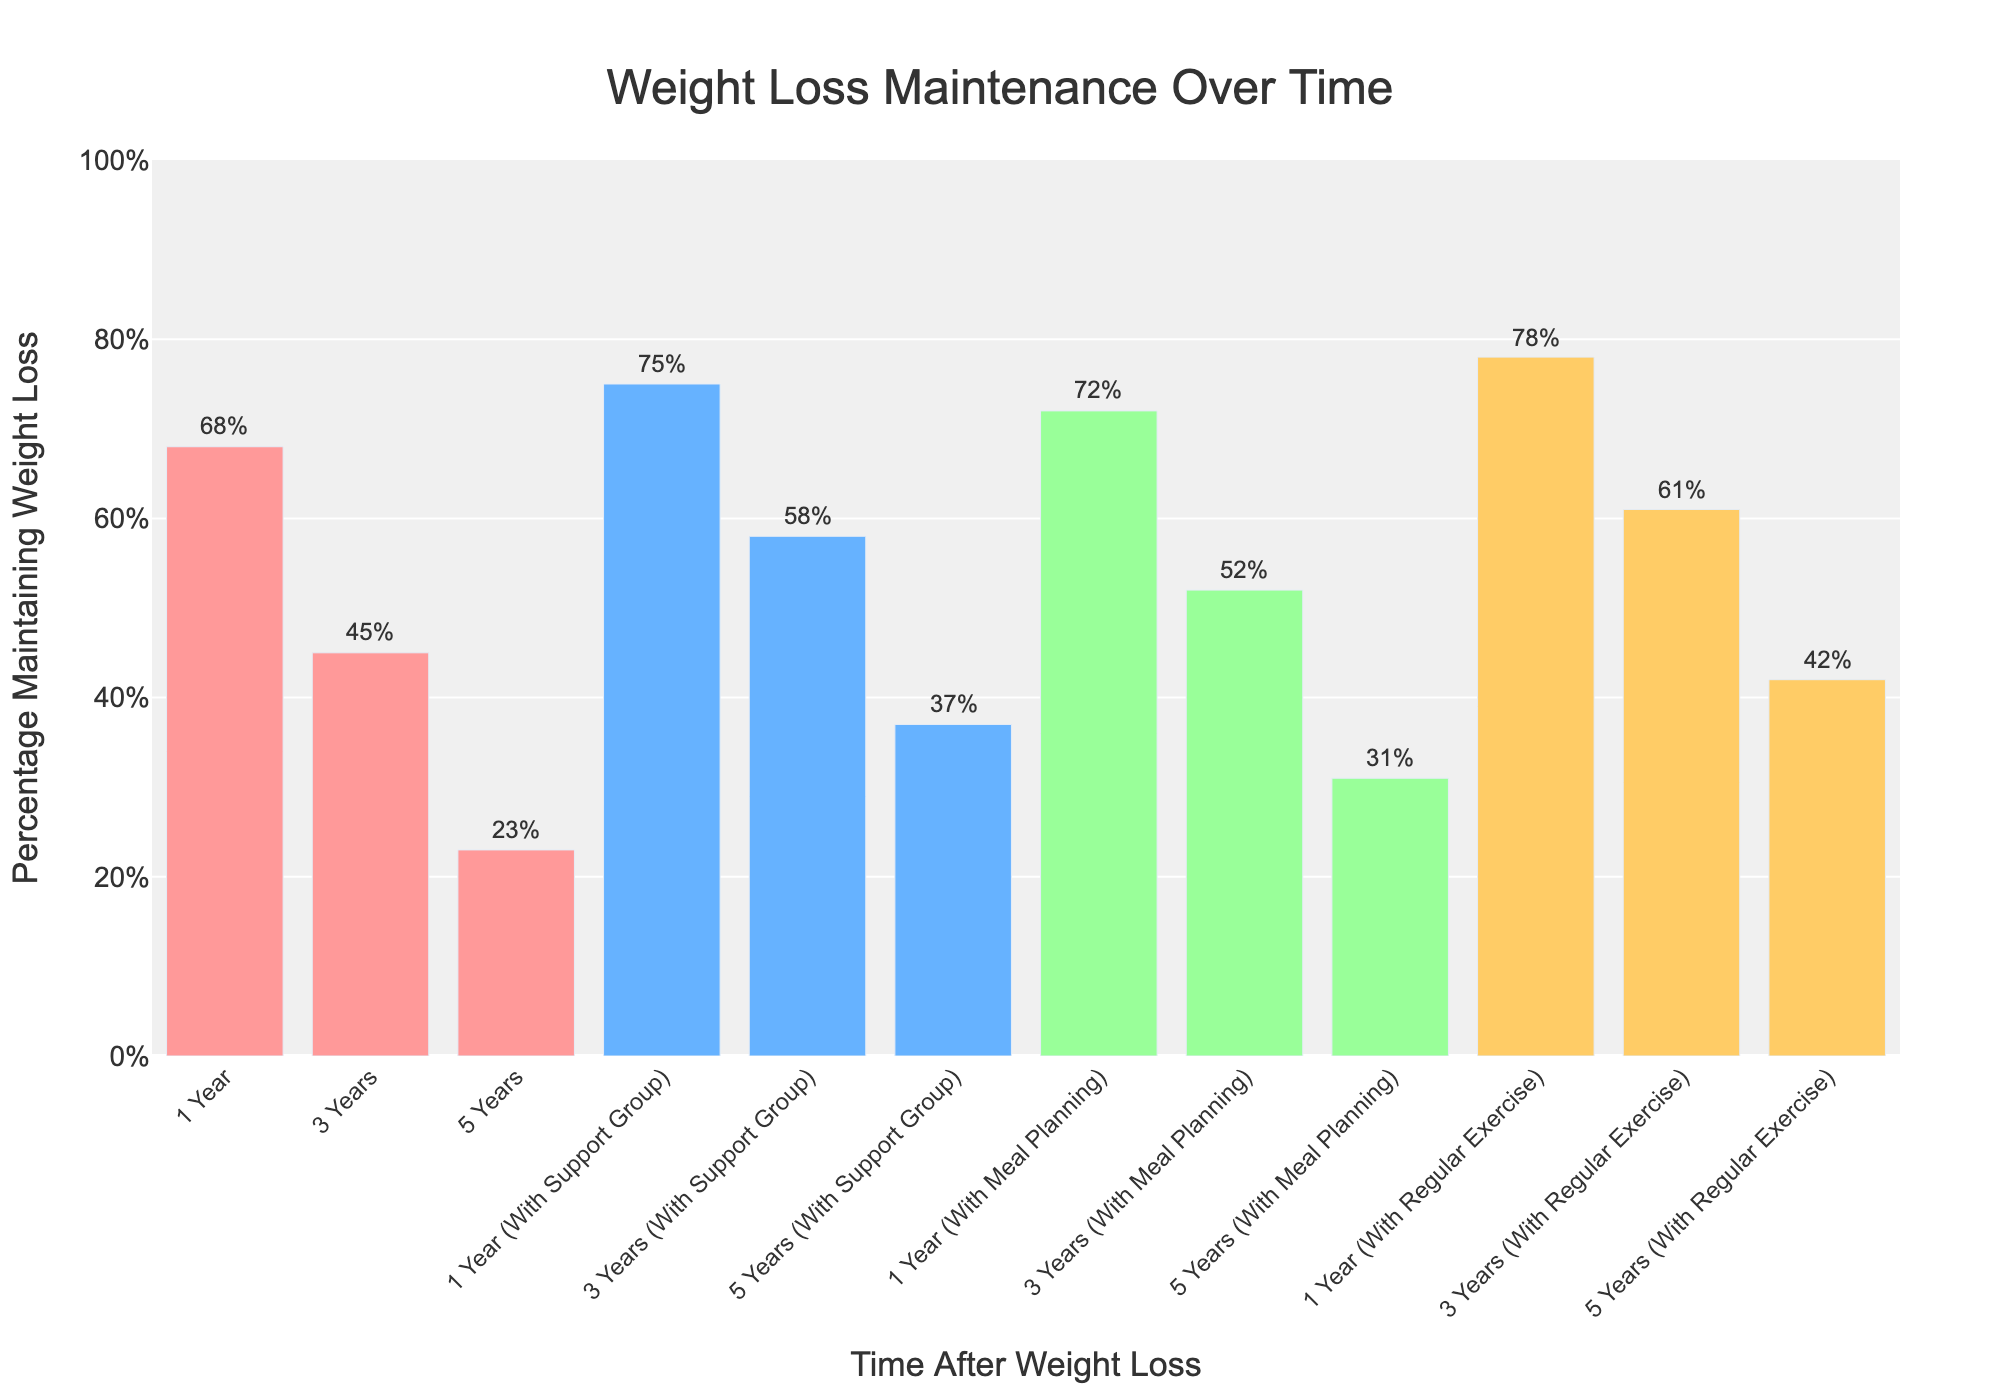Which group has the highest percentage of weight loss maintenance after 1 year? To find the group with the highest percentage of weight loss maintenance after 1 year, we compare the percentages: General (68%), With Support Group (75%), With Meal Planning (72%), and With Regular Exercise (78%). The highest percentage is With Regular Exercise at 78%.
Answer: With Regular Exercise Which group shows the largest decrease in percentage maintaining weight loss from 1 year to 5 years? To determine the largest decrease, we calculate the difference for each group from 1 year to 5 years: General (68% - 23% = 45%), With Support Group (75% - 37% = 38%), With Meal Planning (72% - 31% = 41%), With Regular Exercise (78% - 42% = 36%). The General group has the largest decrease.
Answer: General What is the average percentage of weight loss maintenance after 3 years for all groups? To find the average, sum the percentages of all groups after 3 years: General (45%), With Support Group (58%), With Meal Planning (52%), With Regular Exercise (61%). Then, divide by the number of groups: (45% + 58% + 52% + 61%) / 4 = 54%.
Answer: 54% Which color represents the bars for the "With Regular Exercise" group? The visual attributes show that the bars for the "With Regular Exercise" group are in orange color.
Answer: Orange After 5 years, which group has the smallest percentage of individuals maintaining weight loss? Compare the percentages of all groups after 5 years: General (23%), With Support Group (37%), With Meal Planning (31%), With Regular Exercise (42%). The smallest percentage is in the General group at 23%.
Answer: General How much higher is the percentage of weight loss maintenance with regular exercise after 3 years compared to the general group? The difference between the percentage of weight loss maintenance with regular exercise (61%) and the general group (45%) after 3 years is 61% - 45% = 16%.
Answer: 16% What is the total percentage of weight loss maintenance after 1 year for all combined categories? To find the total, sum the percentages of all categories after 1 year: General (68%), With Support Group (75%), With Meal Planning (72%), With Regular Exercise (78%). The total is 68% + 75% + 72% + 78% = 293%.
Answer: 293% 